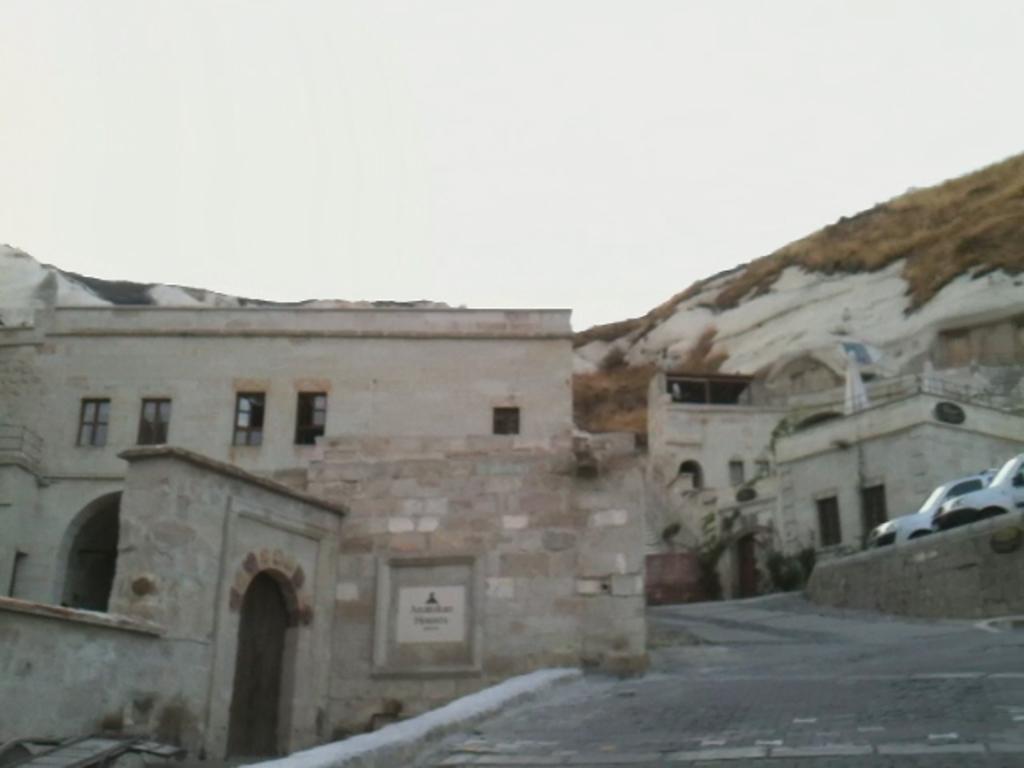Could you give a brief overview of what you see in this image? In this image there are buildings. On the right side of the image there are cars, plants. In the background of the image there is grass and snow on the surface. At the top of the image there is sky. 